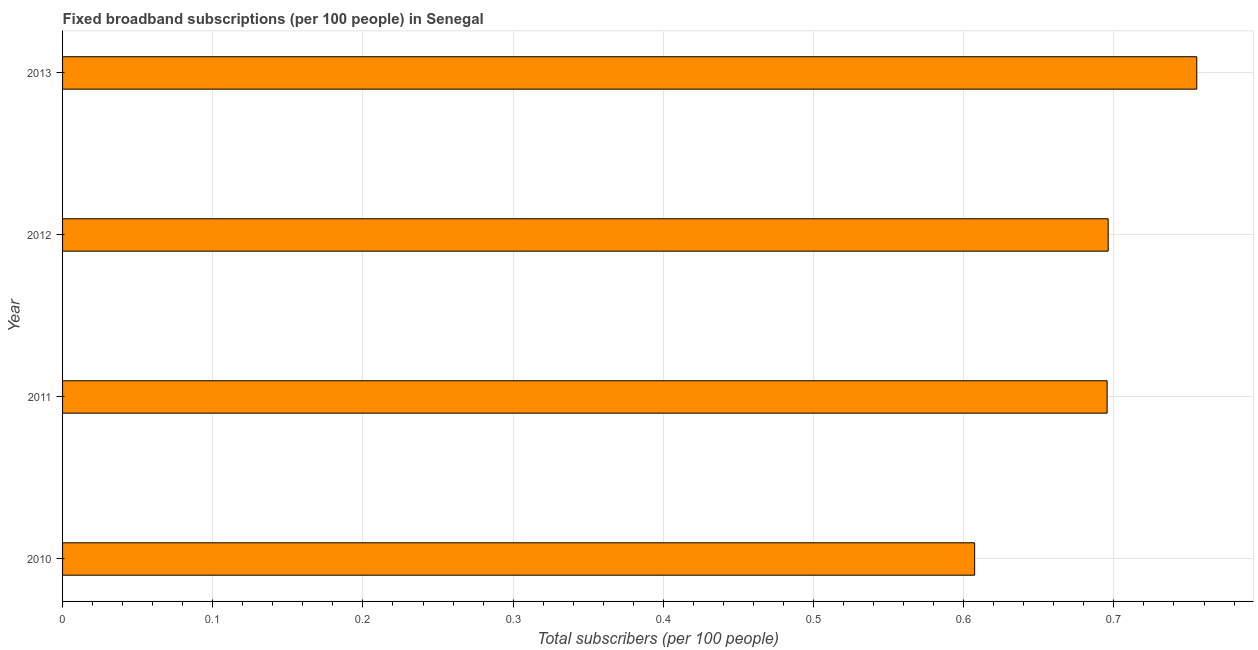What is the title of the graph?
Provide a succinct answer. Fixed broadband subscriptions (per 100 people) in Senegal. What is the label or title of the X-axis?
Offer a very short reply. Total subscribers (per 100 people). What is the total number of fixed broadband subscriptions in 2010?
Provide a short and direct response. 0.61. Across all years, what is the maximum total number of fixed broadband subscriptions?
Your answer should be compact. 0.76. Across all years, what is the minimum total number of fixed broadband subscriptions?
Offer a very short reply. 0.61. In which year was the total number of fixed broadband subscriptions maximum?
Your answer should be compact. 2013. What is the sum of the total number of fixed broadband subscriptions?
Your answer should be very brief. 2.75. What is the difference between the total number of fixed broadband subscriptions in 2010 and 2011?
Provide a succinct answer. -0.09. What is the average total number of fixed broadband subscriptions per year?
Make the answer very short. 0.69. What is the median total number of fixed broadband subscriptions?
Offer a very short reply. 0.7. What is the ratio of the total number of fixed broadband subscriptions in 2011 to that in 2013?
Your answer should be compact. 0.92. What is the difference between the highest and the second highest total number of fixed broadband subscriptions?
Provide a succinct answer. 0.06. Is the sum of the total number of fixed broadband subscriptions in 2010 and 2012 greater than the maximum total number of fixed broadband subscriptions across all years?
Keep it short and to the point. Yes. How many bars are there?
Provide a succinct answer. 4. How many years are there in the graph?
Make the answer very short. 4. What is the Total subscribers (per 100 people) of 2010?
Your answer should be very brief. 0.61. What is the Total subscribers (per 100 people) in 2011?
Keep it short and to the point. 0.7. What is the Total subscribers (per 100 people) of 2012?
Give a very brief answer. 0.7. What is the Total subscribers (per 100 people) in 2013?
Your answer should be compact. 0.76. What is the difference between the Total subscribers (per 100 people) in 2010 and 2011?
Give a very brief answer. -0.09. What is the difference between the Total subscribers (per 100 people) in 2010 and 2012?
Ensure brevity in your answer.  -0.09. What is the difference between the Total subscribers (per 100 people) in 2010 and 2013?
Make the answer very short. -0.15. What is the difference between the Total subscribers (per 100 people) in 2011 and 2012?
Provide a short and direct response. -0. What is the difference between the Total subscribers (per 100 people) in 2011 and 2013?
Your answer should be compact. -0.06. What is the difference between the Total subscribers (per 100 people) in 2012 and 2013?
Your response must be concise. -0.06. What is the ratio of the Total subscribers (per 100 people) in 2010 to that in 2011?
Your answer should be compact. 0.87. What is the ratio of the Total subscribers (per 100 people) in 2010 to that in 2012?
Your response must be concise. 0.87. What is the ratio of the Total subscribers (per 100 people) in 2010 to that in 2013?
Keep it short and to the point. 0.8. What is the ratio of the Total subscribers (per 100 people) in 2011 to that in 2012?
Offer a very short reply. 1. What is the ratio of the Total subscribers (per 100 people) in 2011 to that in 2013?
Provide a short and direct response. 0.92. What is the ratio of the Total subscribers (per 100 people) in 2012 to that in 2013?
Keep it short and to the point. 0.92. 